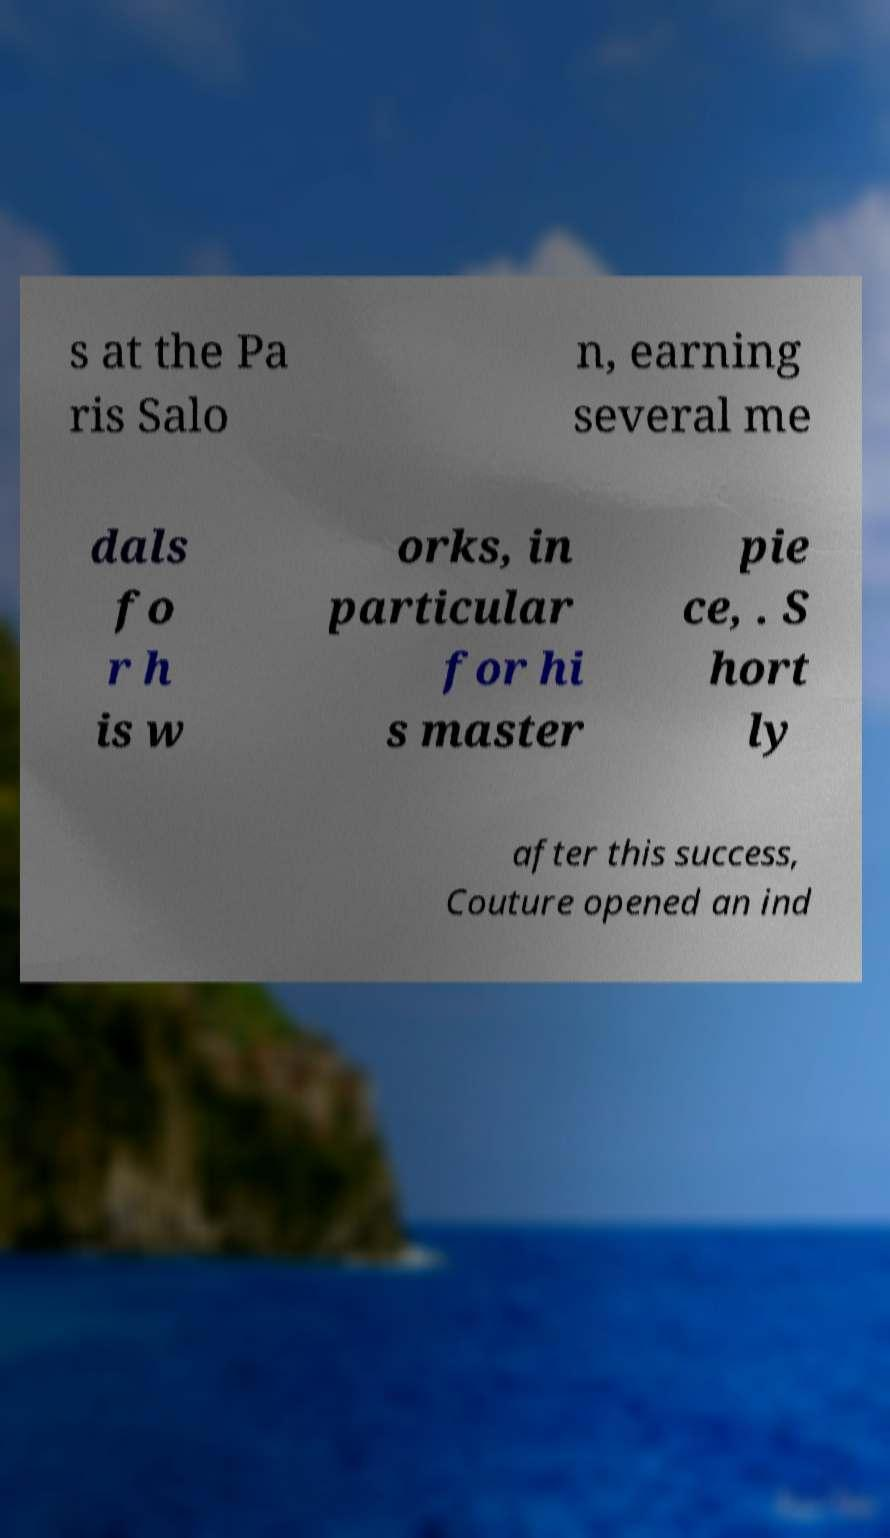There's text embedded in this image that I need extracted. Can you transcribe it verbatim? s at the Pa ris Salo n, earning several me dals fo r h is w orks, in particular for hi s master pie ce, . S hort ly after this success, Couture opened an ind 